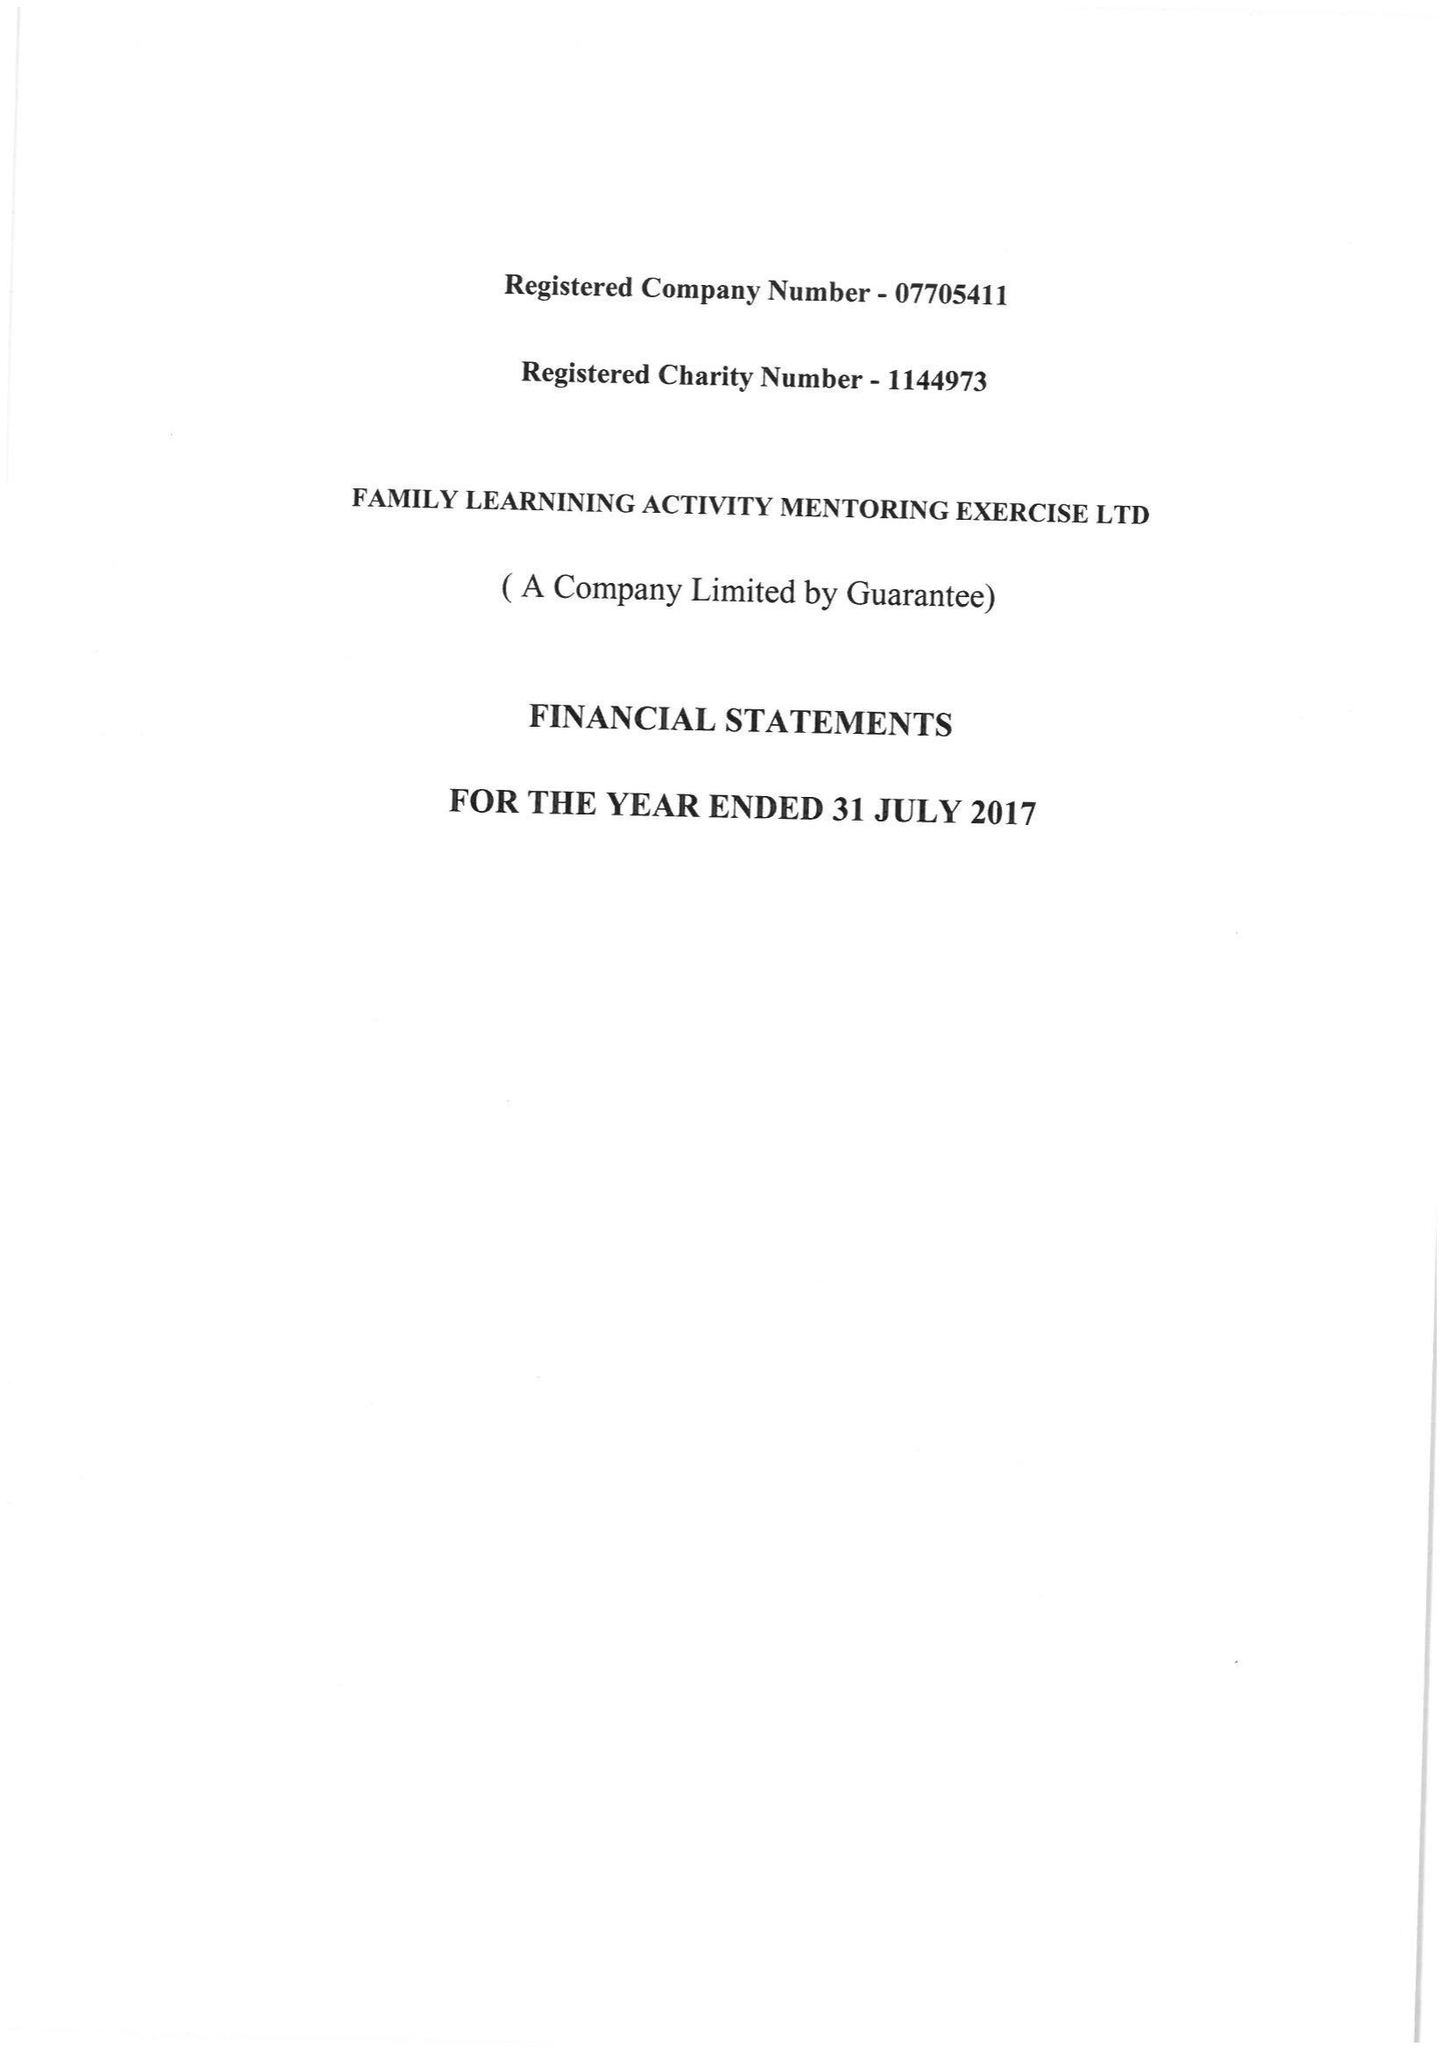What is the value for the address__postcode?
Answer the question using a single word or phrase. W12 0RQ 